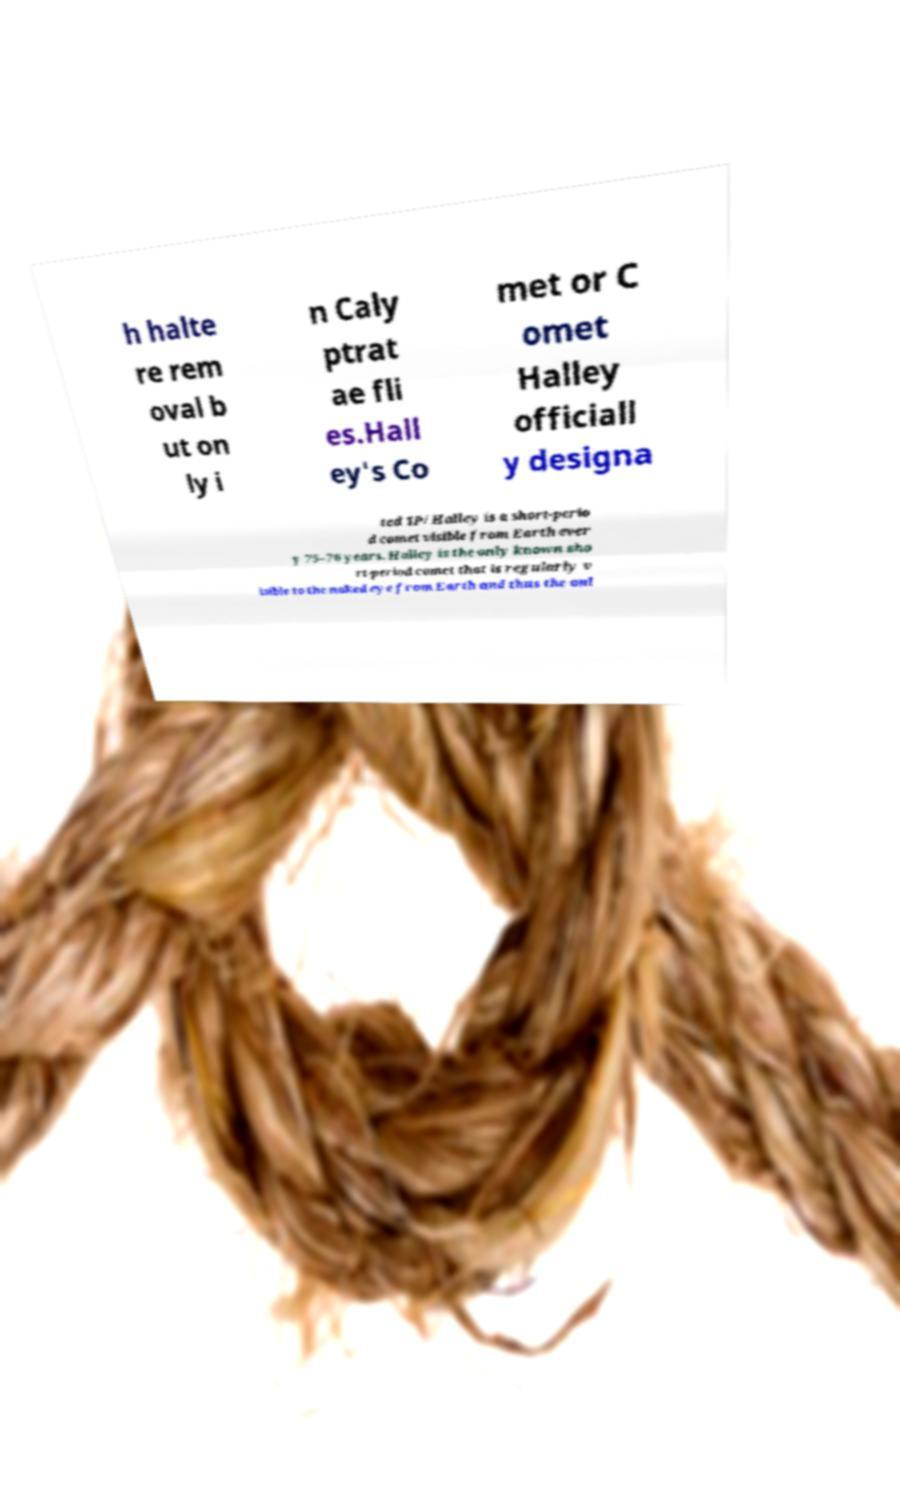Can you read and provide the text displayed in the image?This photo seems to have some interesting text. Can you extract and type it out for me? h halte re rem oval b ut on ly i n Caly ptrat ae fli es.Hall ey's Co met or C omet Halley officiall y designa ted 1P/Halley is a short-perio d comet visible from Earth ever y 75–76 years. Halley is the only known sho rt-period comet that is regularly v isible to the naked eye from Earth and thus the onl 